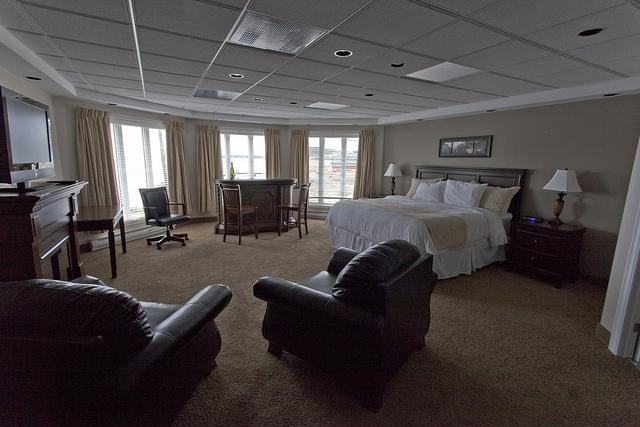What is on the floor?
Be succinct. Carpet. Is the clock plugged in?
Be succinct. Yes. What color are the bed sheets?
Be succinct. White. Is this a library?
Write a very short answer. No. What kind of room is this?
Short answer required. Bedroom. Is the floor clean?
Quick response, please. Yes. Is there a surfboard in the picture?
Short answer required. No. How many chairs are there?
Be succinct. 5. How many people can be seated in this room?
Concise answer only. 5. What color are the tablecloths?
Concise answer only. White. Is there a pattern to the carpet?
Short answer required. No. What would happen if I pushed on one of the squares in the ceiling?
Be succinct. Go up. Are there any seats available?
Quick response, please. Yes. 